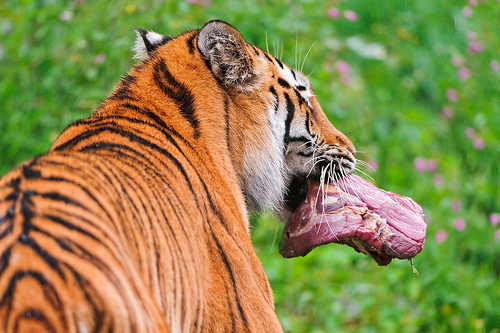<image>
Can you confirm if the tiger is on the meat? Yes. Looking at the image, I can see the tiger is positioned on top of the meat, with the meat providing support. Is there a steak in the tiger? Yes. The steak is contained within or inside the tiger, showing a containment relationship. 